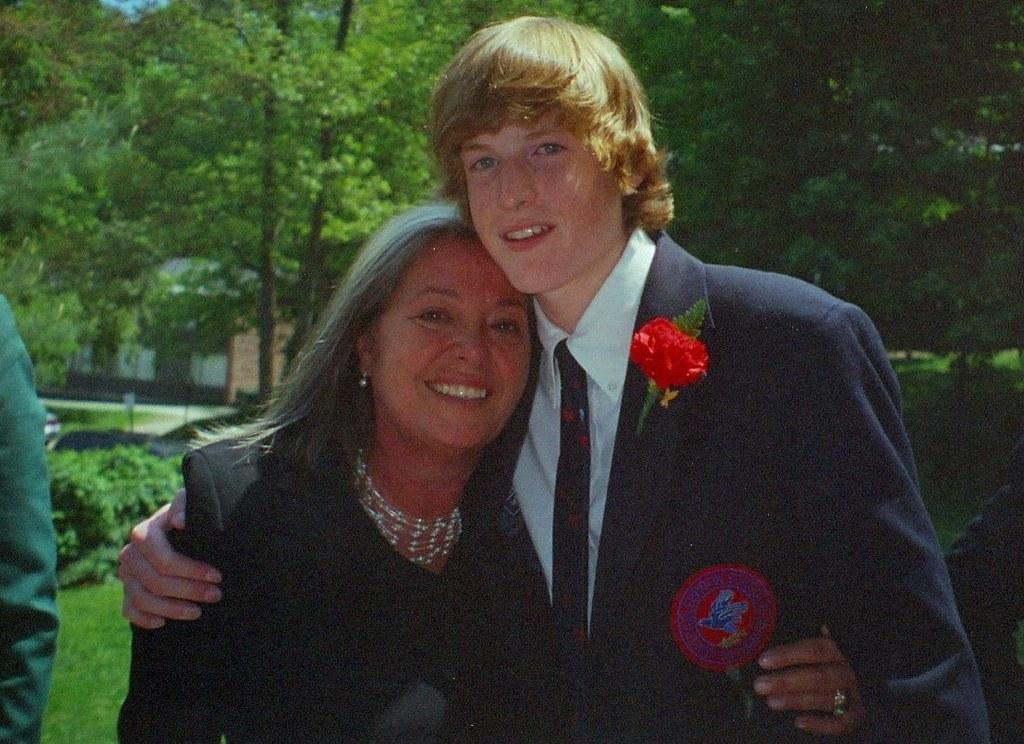Who are the people in the image? There is a woman and a man in the image. Where is the man positioned in the image? The man is standing at the bottom of the image. What can be seen in the background of the image? There are trees in the background of the image. What type of rice is being cooked in the image? There is no rice present in the image. Can you see a bear in the image? No, there is no bear present in the image. 